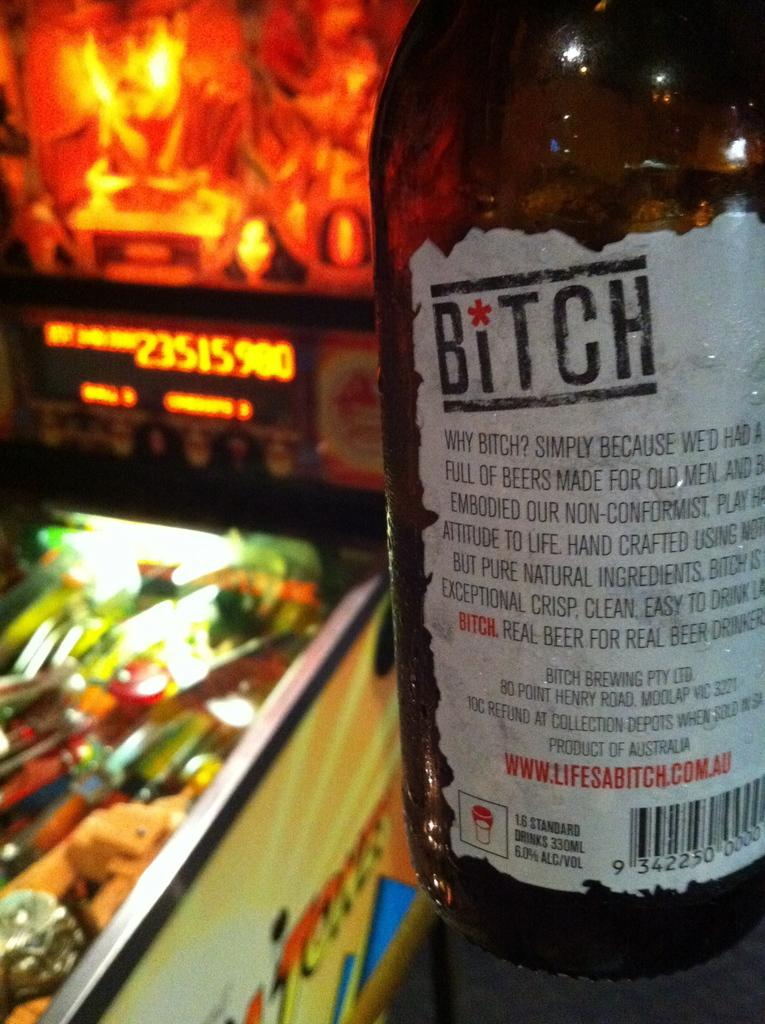Provide a one-sentence caption for the provided image. A bottle of Bitch beer is showing the label as to why its named Bitch. 